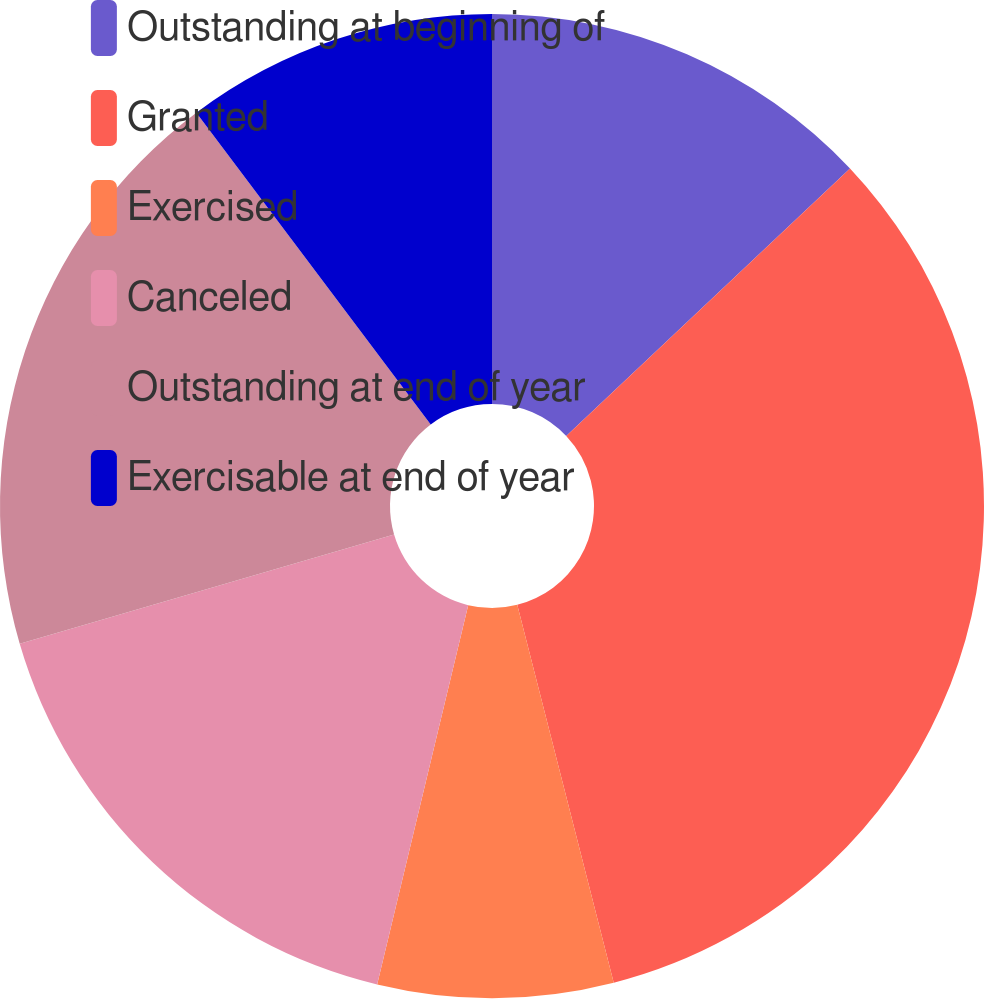Convert chart to OTSL. <chart><loc_0><loc_0><loc_500><loc_500><pie_chart><fcel>Outstanding at beginning of<fcel>Granted<fcel>Exercised<fcel>Canceled<fcel>Outstanding at end of year<fcel>Exercisable at end of year<nl><fcel>12.97%<fcel>33.05%<fcel>7.73%<fcel>16.73%<fcel>19.26%<fcel>10.26%<nl></chart> 